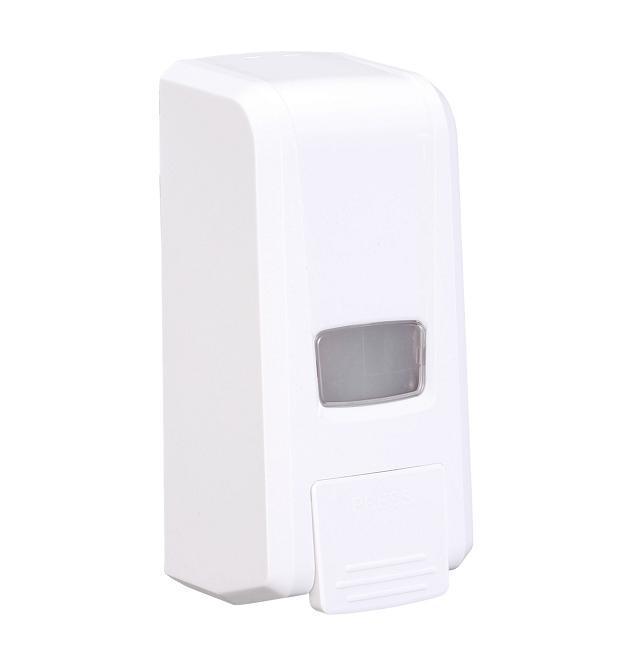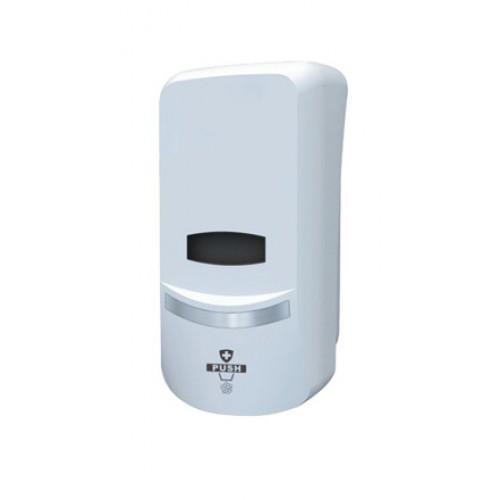The first image is the image on the left, the second image is the image on the right. Given the left and right images, does the statement "The dispenser in the image on the right has a gray button." hold true? Answer yes or no. No. 